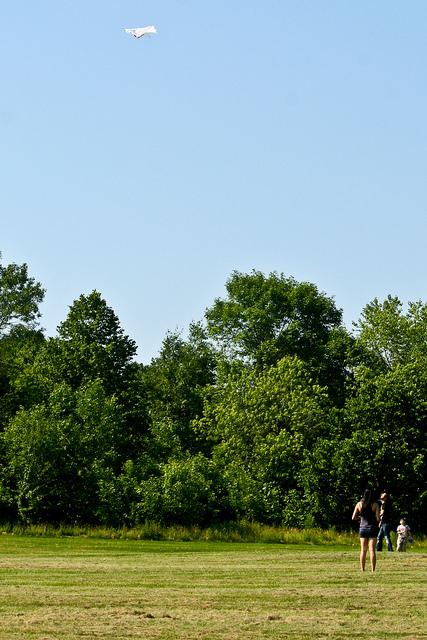How many people are there?
Write a very short answer. 3. What are they looking at?
Quick response, please. Kite. Is there an airplane?
Short answer required. Yes. What is in the air?
Keep it brief. Kite. Are the trees green?
Answer briefly. Yes. 